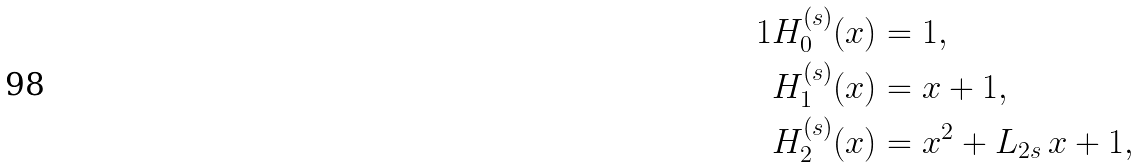<formula> <loc_0><loc_0><loc_500><loc_500>1 H _ { 0 } ^ { ( s ) } ( x ) & = 1 , \\ H _ { 1 } ^ { ( s ) } ( x ) & = x + 1 , \\ H _ { 2 } ^ { ( s ) } ( x ) & = x ^ { 2 } + L _ { 2 s } \, x + 1 ,</formula> 